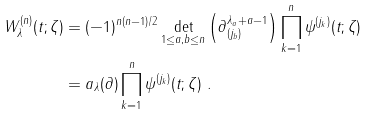<formula> <loc_0><loc_0><loc_500><loc_500>W ^ { ( n ) } _ { \lambda } ( t ; \zeta ) & = ( - 1 ) ^ { n ( n - 1 ) / 2 } \det _ { 1 \leq a , b \leq n } \left ( \partial _ { ( j _ { b } ) } ^ { \lambda _ { a } + a - 1 } \right ) \prod _ { k = 1 } ^ { n } \psi ^ { ( j _ { k } ) } ( t ; \zeta ) \\ & = a _ { \lambda } ( \partial ) \prod _ { k = 1 } ^ { n } \psi ^ { ( j _ { k } ) } ( t ; \zeta ) \ .</formula> 